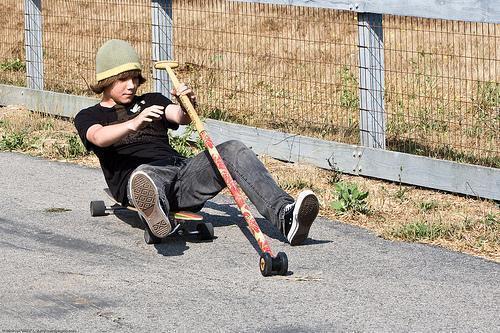How many people are there in the picture?
Give a very brief answer. 1. 